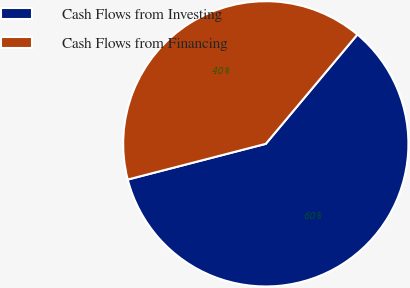<chart> <loc_0><loc_0><loc_500><loc_500><pie_chart><fcel>Cash Flows from Investing<fcel>Cash Flows from Financing<nl><fcel>59.87%<fcel>40.13%<nl></chart> 